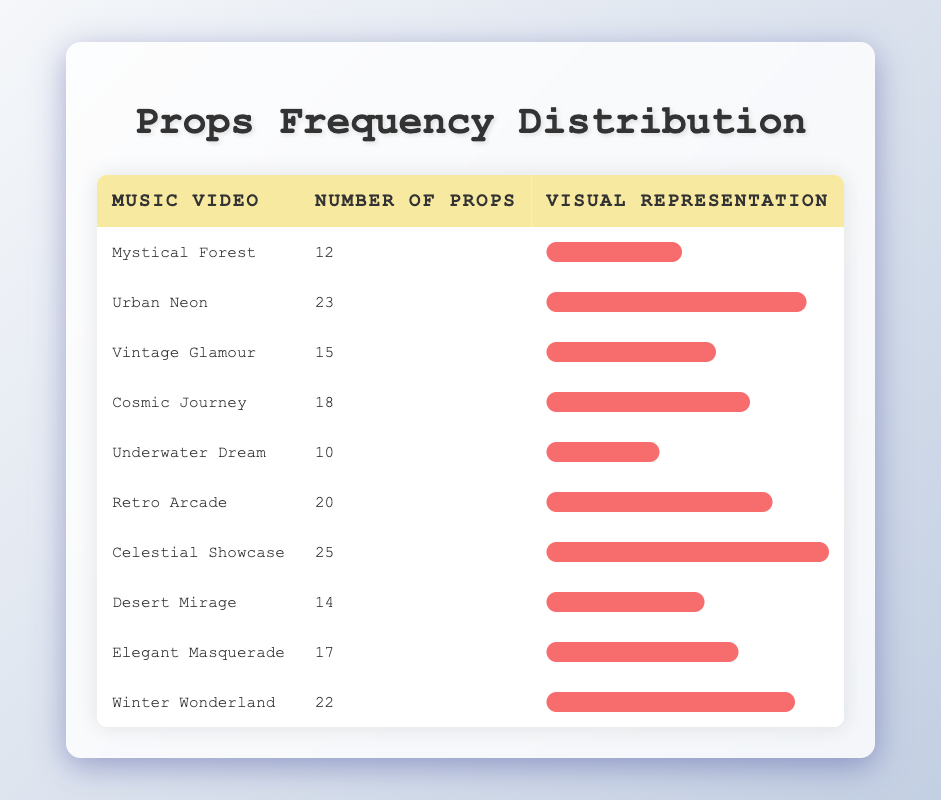What is the highest number of props used in a music video? The table shows the number of props used in various music videos. Looking through the "Number of Props" column, the highest value is 25, which corresponds to the music video "Celestial Showcase."
Answer: 25 Which music video used the least number of props? By scanning the "Number of Props" column, the music video with the lowest entry is "Underwater Dream," which has 10 props.
Answer: Underwater Dream What is the average number of props used across all music videos? To find the average, first, sum the number of props: 12 + 23 + 15 + 18 + 10 + 20 + 25 + 14 + 17 + 22 =  171. Then, divide this sum by the number of music videos, which is 10. Thus, 171 / 10 = 17.1.
Answer: 17.1 Is there a music video that has exactly 20 props used? A review of the table indicates that "Retro Arcade" is associated with exactly 20 props, confirming that there is a music video with this exact count.
Answer: Yes How many music videos utilized more than 18 props? By examining the "Number of Props" column, the music videos that have more than 18 props are: "Urban Neon" (23), "Cosmic Journey" (18), "Retro Arcade" (20), "Celestial Showcase" (25), and "Winter Wonderland" (22). Counting these gives us a total of 5 music videos that meet the criterion.
Answer: 5 